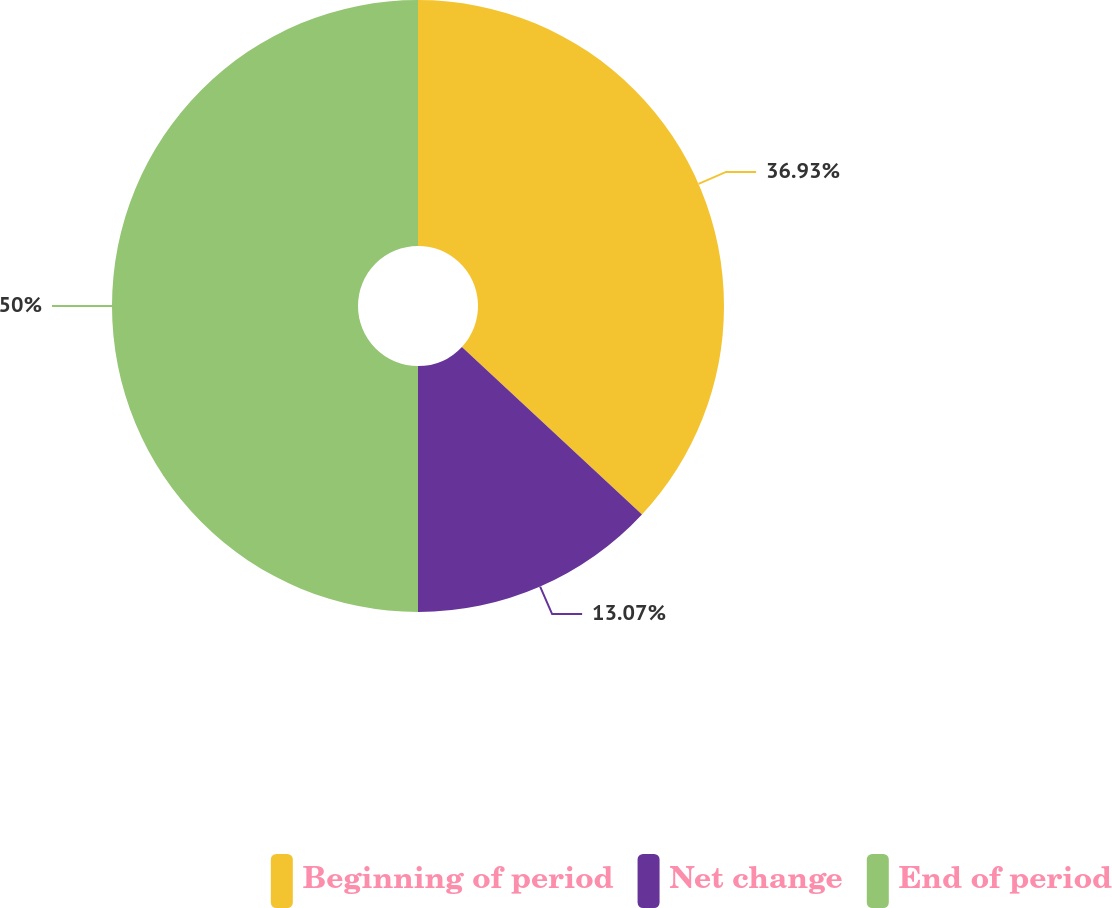Convert chart. <chart><loc_0><loc_0><loc_500><loc_500><pie_chart><fcel>Beginning of period<fcel>Net change<fcel>End of period<nl><fcel>36.93%<fcel>13.07%<fcel>50.0%<nl></chart> 